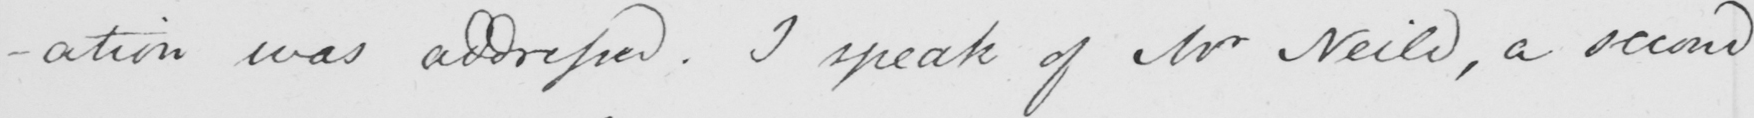What does this handwritten line say? -ation was addressed . I speak of Mr Neild , a second 